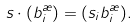<formula> <loc_0><loc_0><loc_500><loc_500>s \cdot ( b _ { i } ^ { \rho } ) = ( s _ { i } b _ { i } ^ { \rho } ) .</formula> 